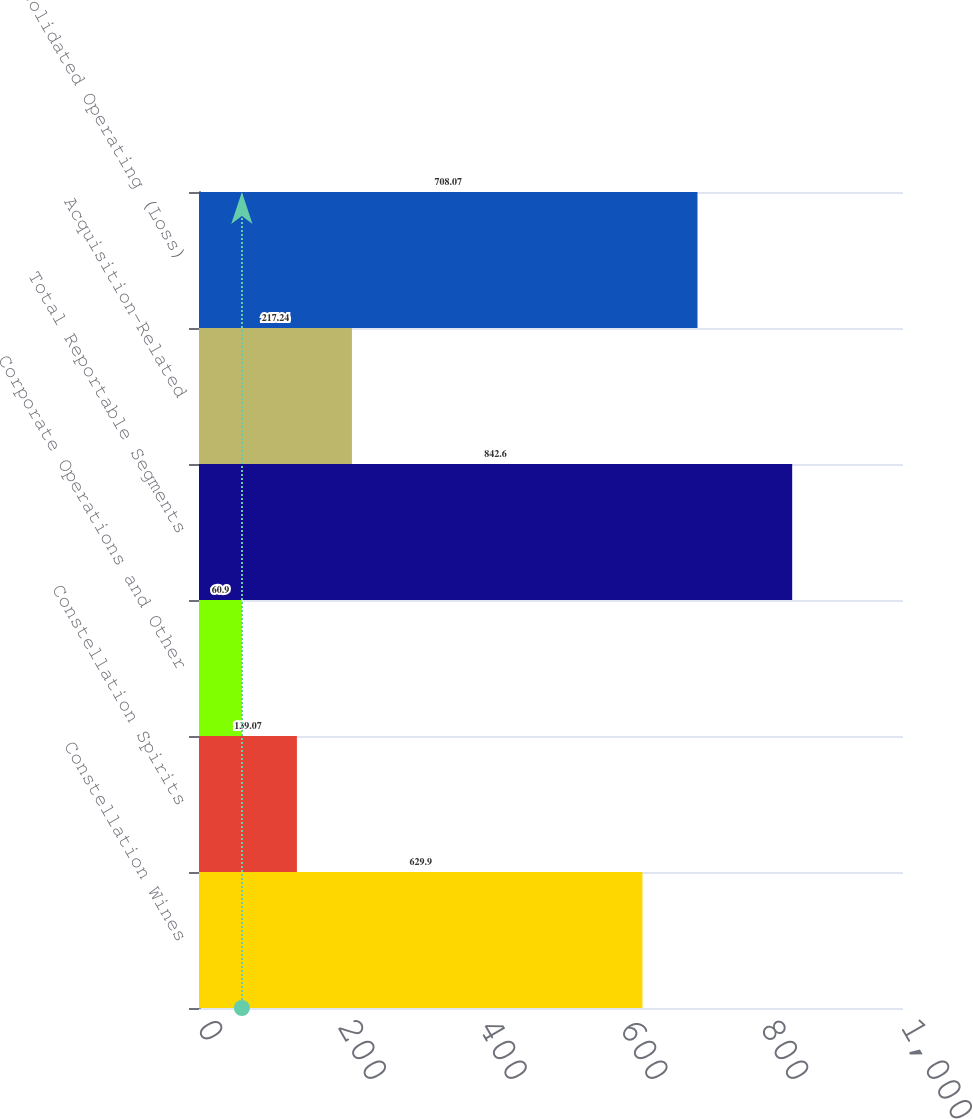<chart> <loc_0><loc_0><loc_500><loc_500><bar_chart><fcel>Constellation Wines<fcel>Constellation Spirits<fcel>Corporate Operations and Other<fcel>Total Reportable Segments<fcel>Acquisition-Related<fcel>Consolidated Operating (Loss)<nl><fcel>629.9<fcel>139.07<fcel>60.9<fcel>842.6<fcel>217.24<fcel>708.07<nl></chart> 